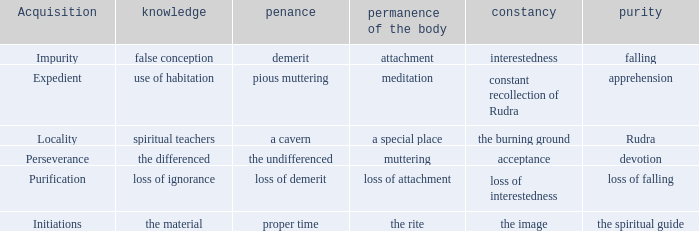 what's the permanence of the body where constancy is interestedness Attachment. 